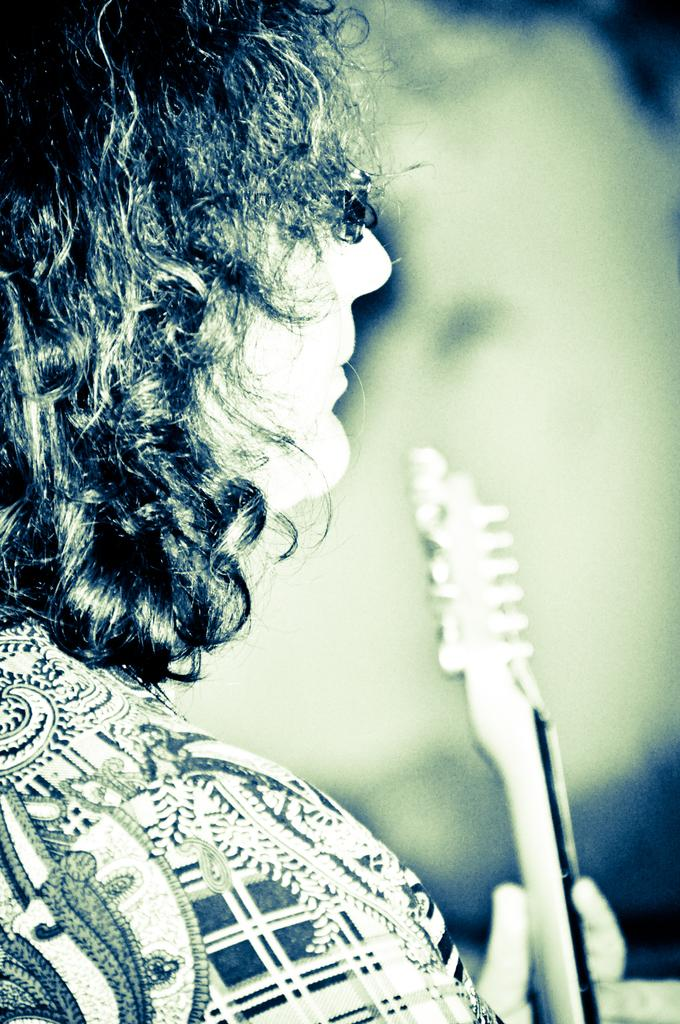What is the main subject of the image? There is a person in the image. What is the person holding in the image? The person is holding a musical instrument. Can you describe the background of the image? The background of the image is blurry. How many nails are visible in the image? There are no nails visible in the image. Is the person in the image taking a flight? There is no indication of a flight or any travel-related activity in the image. 